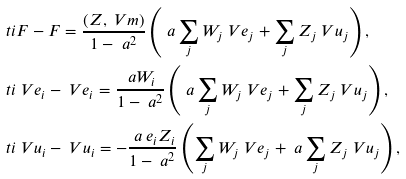Convert formula to latex. <formula><loc_0><loc_0><loc_500><loc_500>& \ t i F - F = \frac { ( Z , \ V m ) } { 1 - \ a ^ { 2 } } \left ( \ a \sum _ { j } W _ { j } \ V e _ { j } + \sum _ { j } Z _ { j } \ V u _ { j } \right ) , \\ & \ t i { \ V e } _ { i } - \ V e _ { i } = \frac { \ a W _ { i } } { 1 - \ a ^ { 2 } } \left ( \ a \sum _ { j } W _ { j } \ V e _ { j } + \sum _ { j } Z _ { j } \ V u _ { j } \right ) , \\ & \ t i { \ V u } _ { i } - \ V u _ { i } = - \frac { \ a \ e _ { i } Z _ { i } } { 1 - \ a ^ { 2 } } \left ( \sum _ { j } W _ { j } \ V e _ { j } + \ a \sum _ { j } Z _ { j } \ V u _ { j } \right ) ,</formula> 